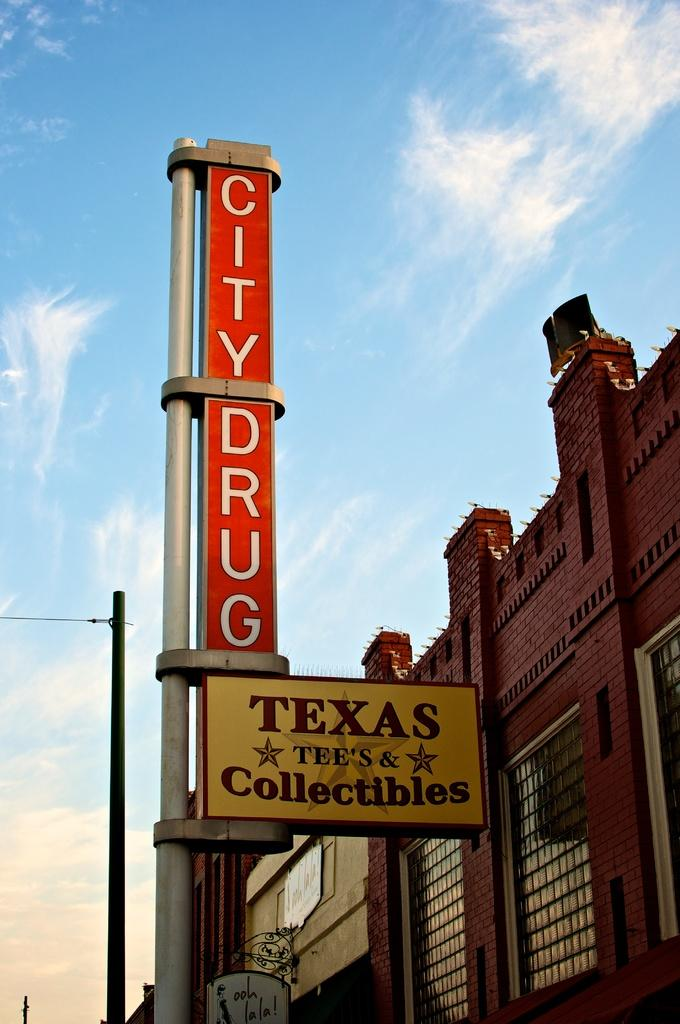What is written on the pole in the foreground of the image? The words "City drug" are written on the pole in the foreground of the image. What can be seen in the background of the image? There is a building and a pole in the background of the image, as well as clouds and the sky. What type of drum does the mom play in the image? There is no mom or drum present in the image. 